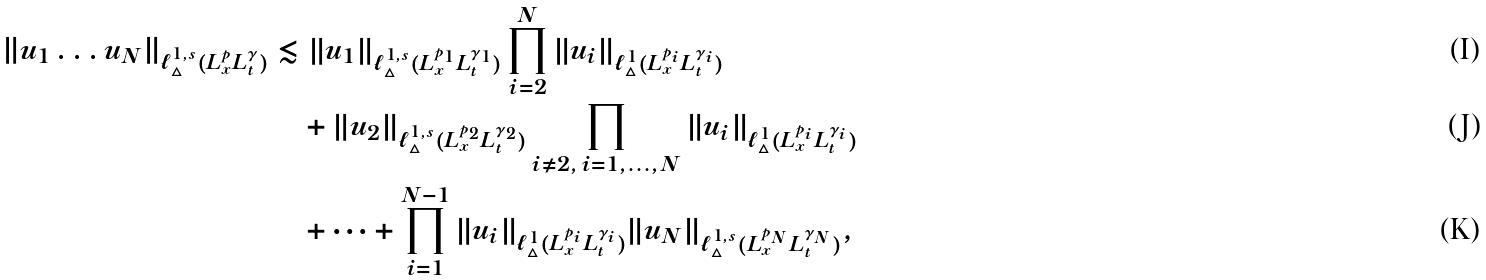<formula> <loc_0><loc_0><loc_500><loc_500>\left \| u _ { 1 } \dots u _ { N } \right \| _ { \ell _ { \triangle } ^ { 1 , s } ( L ^ { p } _ { x } L ^ { \gamma } _ { t } ) } & \lesssim \| u _ { 1 } \| _ { \ell _ { \triangle } ^ { 1 , s } ( L ^ { p _ { 1 } } _ { x } L ^ { \gamma _ { 1 } } _ { t } ) } \prod ^ { N } _ { i = 2 } \| u _ { i } \| _ { \ell _ { \triangle } ^ { 1 } ( L ^ { p _ { i } } _ { x } L ^ { \gamma _ { i } } _ { t } ) } \\ & \quad + \| u _ { 2 } \| _ { \ell _ { \triangle } ^ { 1 , s } ( L ^ { p _ { 2 } } _ { x } L ^ { \gamma _ { 2 } } _ { t } ) } \prod _ { i \not = 2 , \, i = 1 , \dots , N } \| u _ { i } \| _ { \ell _ { \triangle } ^ { 1 } ( L ^ { p _ { i } } _ { x } L ^ { \gamma _ { i } } _ { t } ) } \\ & \quad + \dots + \prod ^ { N - 1 } _ { i = 1 } \| u _ { i } \| _ { \ell _ { \triangle } ^ { 1 } ( L ^ { p _ { i } } _ { x } L ^ { \gamma _ { i } } _ { t } ) } \| u _ { N } \| _ { \ell _ { \triangle } ^ { 1 , s } ( L ^ { p _ { N } } _ { x } L ^ { \gamma _ { N } } _ { t } ) } ,</formula> 